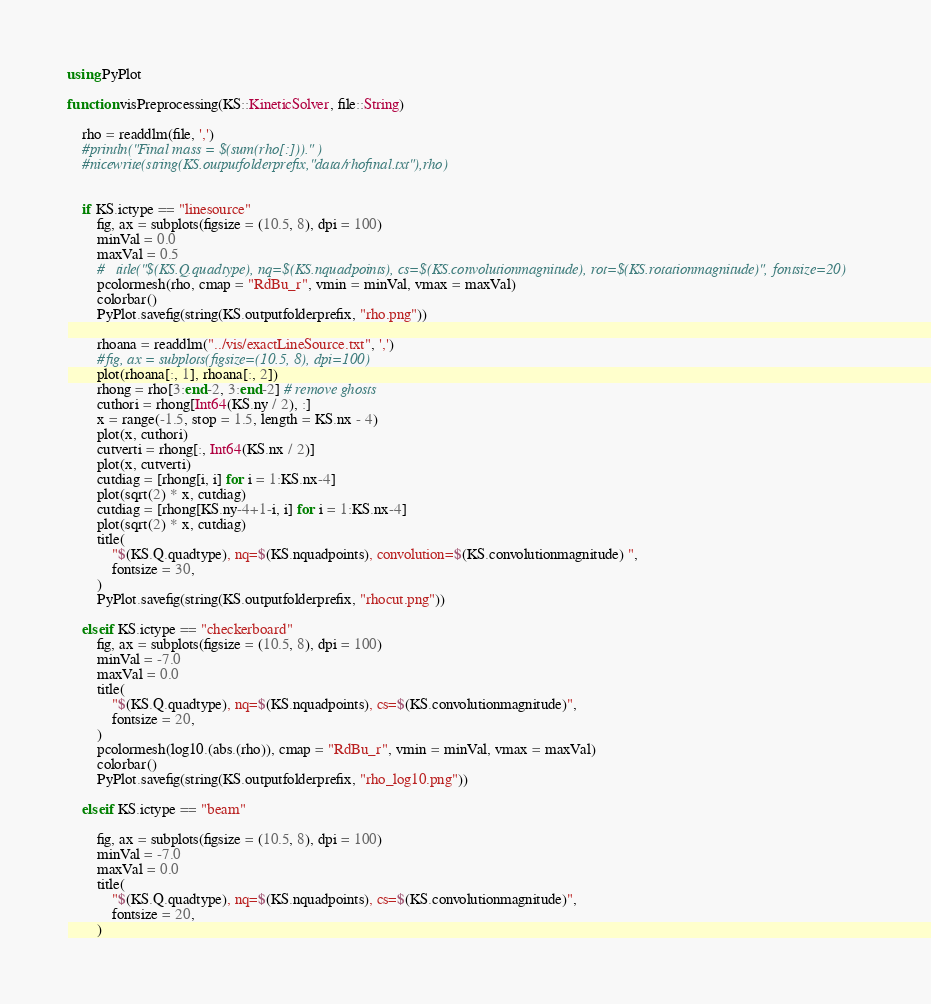Convert code to text. <code><loc_0><loc_0><loc_500><loc_500><_Julia_>using PyPlot

function visPreprocessing(KS::KineticSolver, file::String)

    rho = readdlm(file, ',')
    #println("Final mass = $(sum(rho[:]))." ) 
    #nicewrite(string(KS.outputfolderprefix,"data/rhofinal.txt"),rho)


    if KS.ictype == "linesource"
        fig, ax = subplots(figsize = (10.5, 8), dpi = 100)
        minVal = 0.0
        maxVal = 0.5
        #	title("$(KS.Q.quadtype), nq=$(KS.nquadpoints), cs=$(KS.convolutionmagnitude), rot=$(KS.rotationmagnitude)", fontsize=20)
        pcolormesh(rho, cmap = "RdBu_r", vmin = minVal, vmax = maxVal)
        colorbar()
        PyPlot.savefig(string(KS.outputfolderprefix, "rho.png"))

        rhoana = readdlm("../vis/exactLineSource.txt", ',')
        #fig, ax = subplots(figsize=(10.5, 8), dpi=100)
        plot(rhoana[:, 1], rhoana[:, 2])
        rhong = rho[3:end-2, 3:end-2] # remove ghosts
        cuthori = rhong[Int64(KS.ny / 2), :]
        x = range(-1.5, stop = 1.5, length = KS.nx - 4)
        plot(x, cuthori)
        cutverti = rhong[:, Int64(KS.nx / 2)]
        plot(x, cutverti)
        cutdiag = [rhong[i, i] for i = 1:KS.nx-4]
        plot(sqrt(2) * x, cutdiag)
        cutdiag = [rhong[KS.ny-4+1-i, i] for i = 1:KS.nx-4]
        plot(sqrt(2) * x, cutdiag)
        title(
            "$(KS.Q.quadtype), nq=$(KS.nquadpoints), convolution=$(KS.convolutionmagnitude) ",
            fontsize = 30,
        )
        PyPlot.savefig(string(KS.outputfolderprefix, "rhocut.png"))

    elseif KS.ictype == "checkerboard"
        fig, ax = subplots(figsize = (10.5, 8), dpi = 100)
        minVal = -7.0
        maxVal = 0.0
        title(
            "$(KS.Q.quadtype), nq=$(KS.nquadpoints), cs=$(KS.convolutionmagnitude)",
            fontsize = 20,
        )
        pcolormesh(log10.(abs.(rho)), cmap = "RdBu_r", vmin = minVal, vmax = maxVal)
        colorbar()
        PyPlot.savefig(string(KS.outputfolderprefix, "rho_log10.png"))

    elseif KS.ictype == "beam"

        fig, ax = subplots(figsize = (10.5, 8), dpi = 100)
        minVal = -7.0
        maxVal = 0.0
        title(
            "$(KS.Q.quadtype), nq=$(KS.nquadpoints), cs=$(KS.convolutionmagnitude)",
            fontsize = 20,
        )</code> 